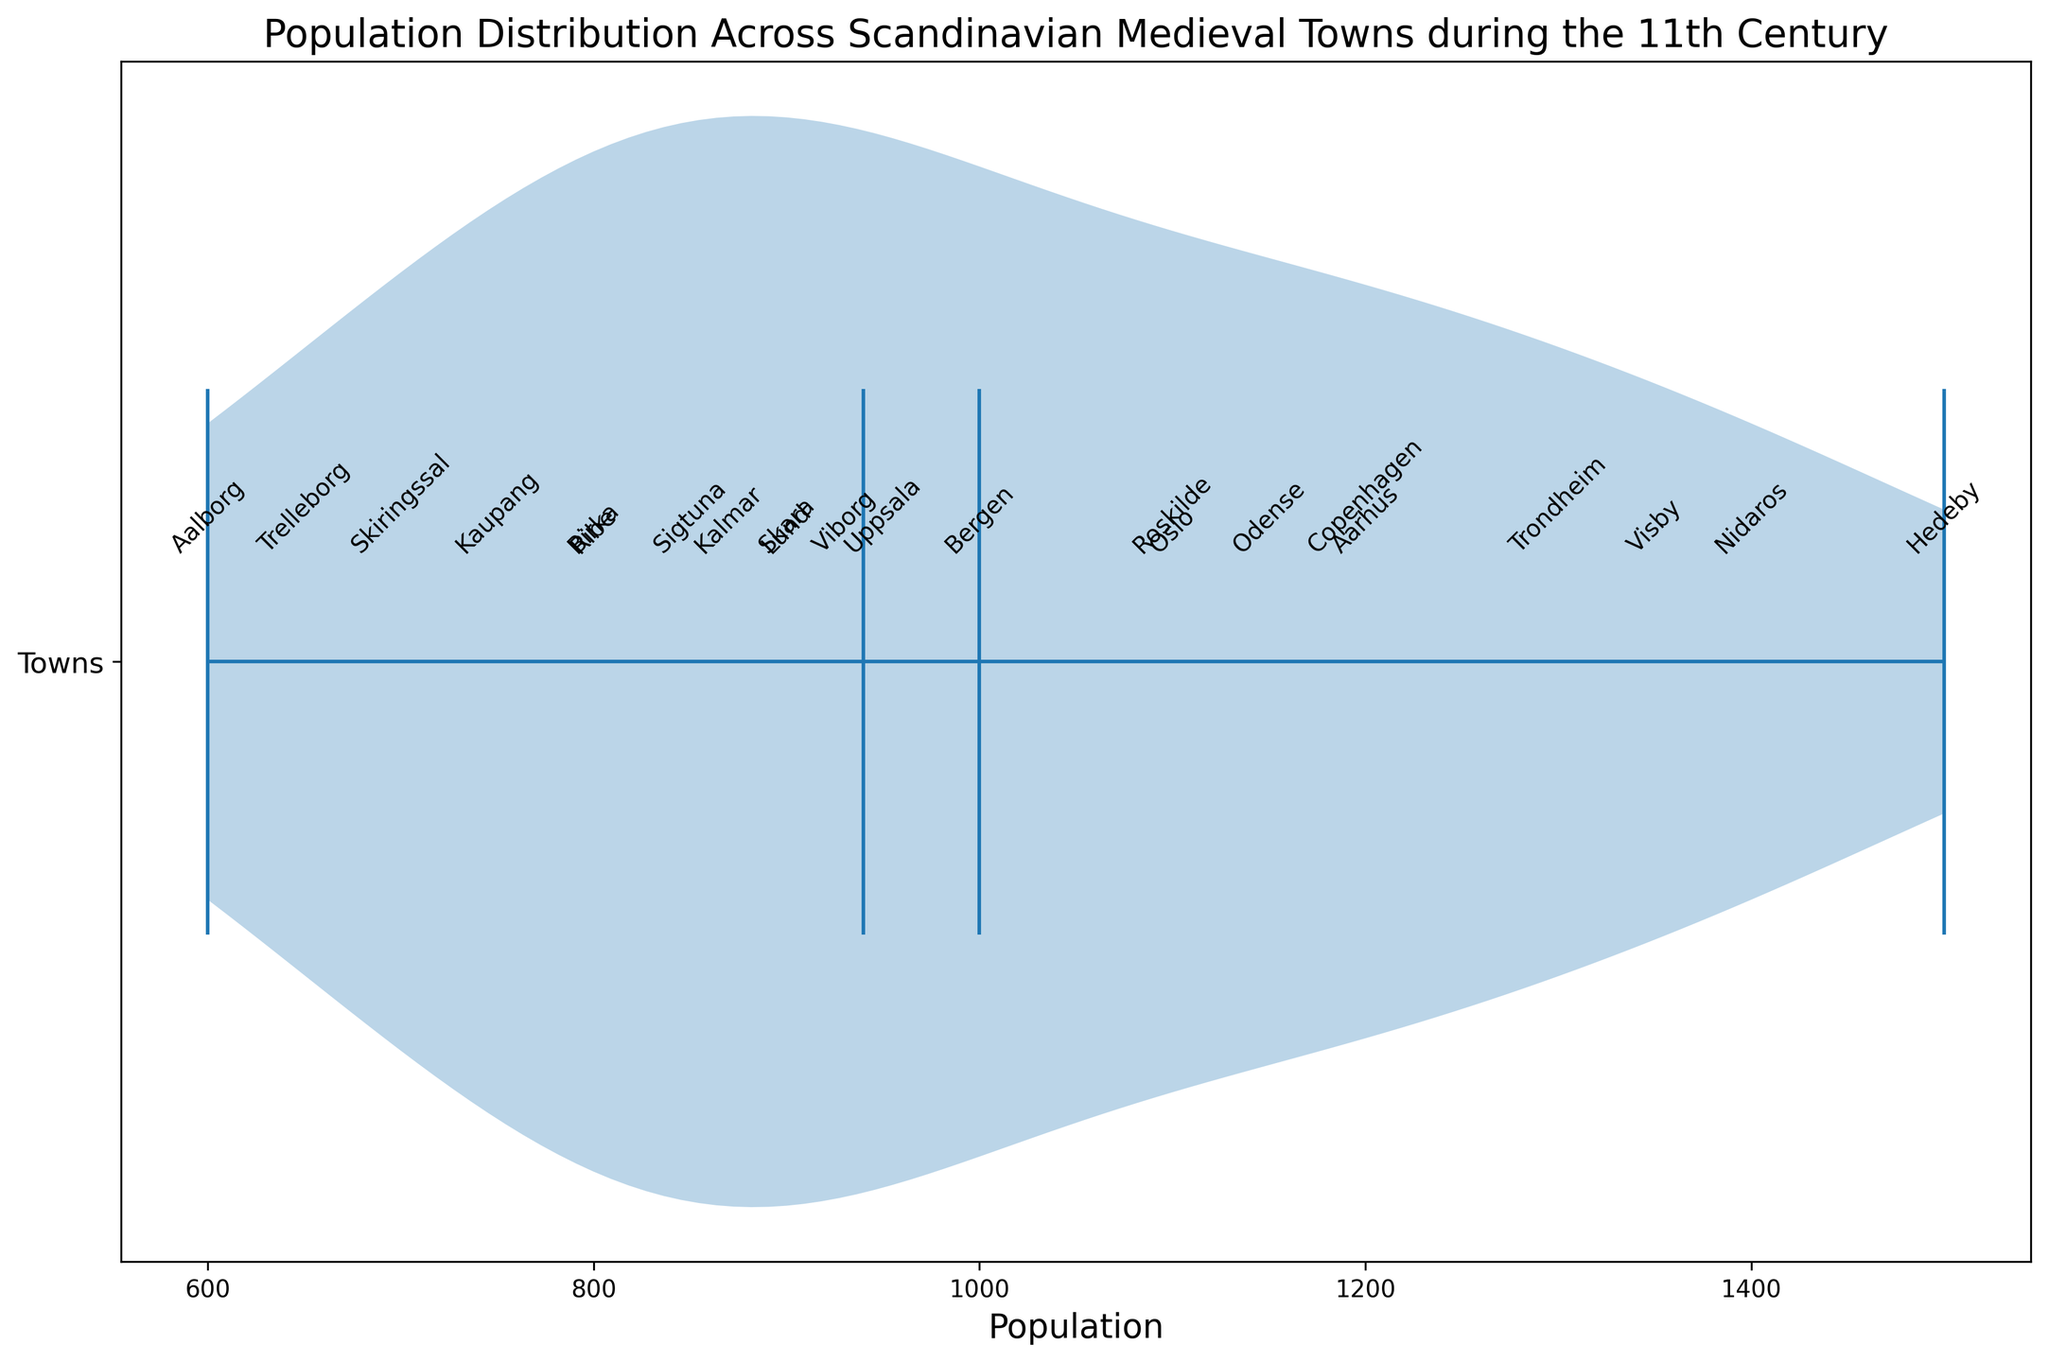What is the mean population of the Scandinavian medieval towns during the 11th century? To find the mean, sum all the population values and divide by the number of towns. The total population is 21,550, and there are 22 towns. Therefore, the mean population is 21,550 / 22 = 979.55
Answer: 979.55 What does the median value indicate in the violin plot? The median is represented by a horizontal line in the middle of the distribution. It indicates the middle value of the population data when arranged in descending order. Looking at the plot, the median value of the population is at 950.
Answer: 950 Which town has the highest population? By observing the marked towns on the violin plot, Hedeby has the highest population, which is labeled at 1500.
Answer: Hedeby How does the population of Trondheim compare to that of Odense? The text markers on the plot show that Trondheim has a population of 1300 and Odense has a population of 1150. Therefore, Trondheim has a higher population than Odense.
Answer: Trondheim Identify the town with the lowest population. The plot indicates that Aalborg has the lowest population among the towns, which is marked at 600.
Answer: Aalborg What range of populations does the violin plot cover? The range can be determined by subtracting the smallest population value from the largest. The highest is 1500 (Hedeby), and the lowest is 600 (Aalborg), so the range is 1500 - 600 = 900.
Answer: 900 What does the width of the violin plot at various points tell us about the population distribution? The width of the violin plot at any given point shows the density of towns with populations around that value. Wider sections represent more towns with similar populations, while narrower sections indicate fewer towns. The plot is widest around the median, suggesting many towns have populations near the median value.
Answer: Density of towns' populations How do the mean and median populations compare in the violin plot? The mean is marked by a dot and the median by a line. The mean value (approximately 979.55) is slightly above the median (950), suggesting a right-skewed distribution where some towns have significantly higher populations.
Answer: Mean > Median What does the presence of multiple peaks in the violin plot suggest? Multiple peaks in a violin plot indicate the presence of clusters or groups within the data. In this case, some towns might cluster around mid-range populations while others around higher or lower populations, suggesting non-uniform distribution.
Answer: Population clusters Which towns have populations closest to the mean value? Observing towns around the mean (979.55), Lund (900), Uppsala (950), Skara (900), Kalmar (870), Viborg (930), and Odense (1150) have populations relatively close to the mean.
Answer: Lund, Uppsala, Skara, Kalmar, Viborg, Odense 